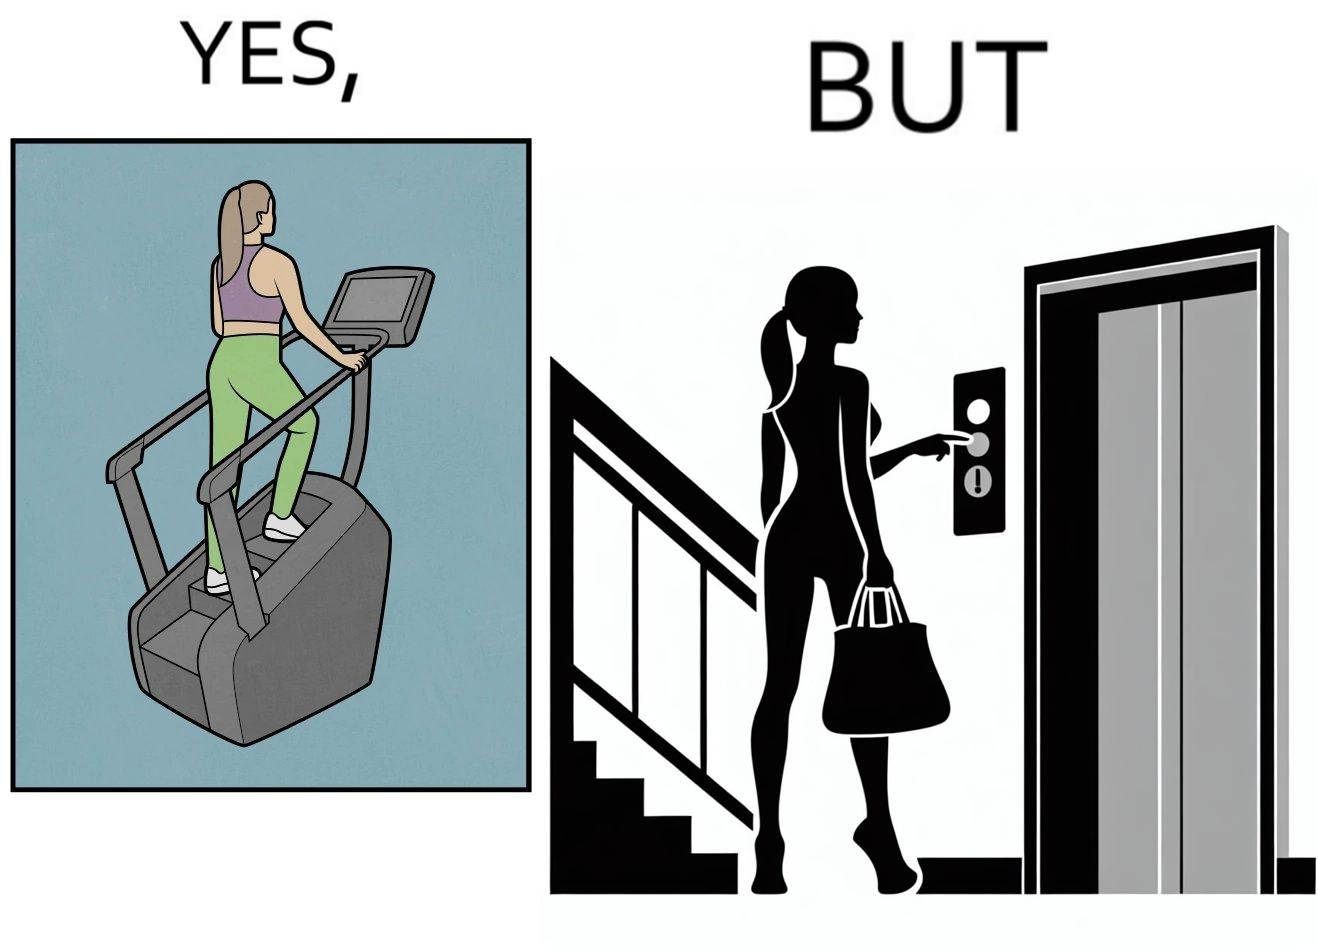What makes this image funny or satirical? The image is ironic, because in the left image a woman is seen using the stair climber machine at the gym but the same woman is not ready to climb up some stairs for going to the gym and is calling for the lift 